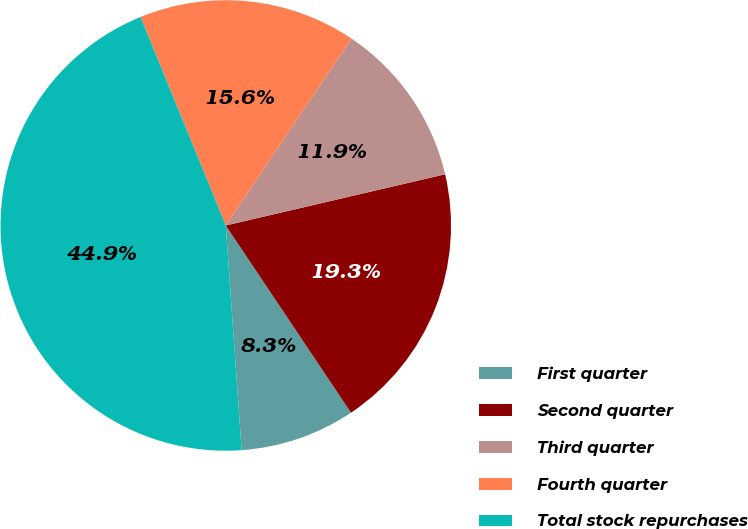<chart> <loc_0><loc_0><loc_500><loc_500><pie_chart><fcel>First quarter<fcel>Second quarter<fcel>Third quarter<fcel>Fourth quarter<fcel>Total stock repurchases<nl><fcel>8.26%<fcel>19.27%<fcel>11.93%<fcel>15.6%<fcel>44.95%<nl></chart> 